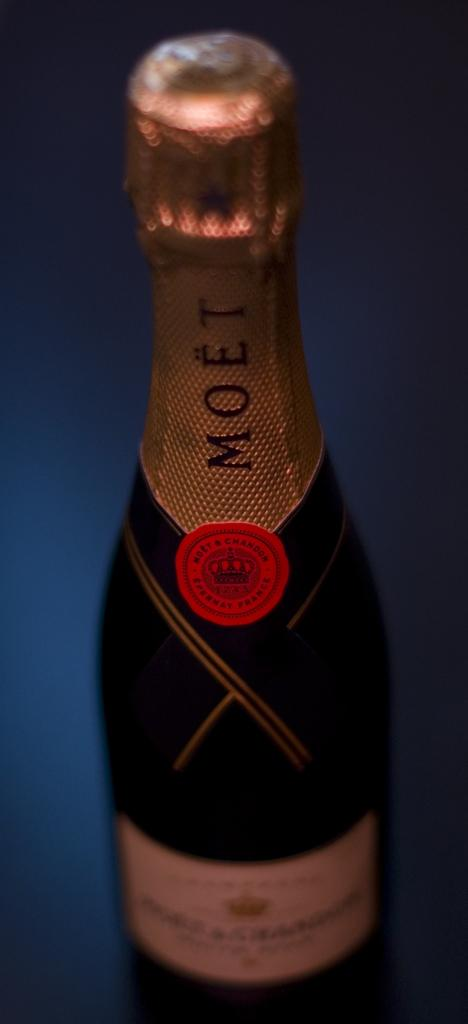<image>
Render a clear and concise summary of the photo. A bottle of Moet champagne sitting on a table. 